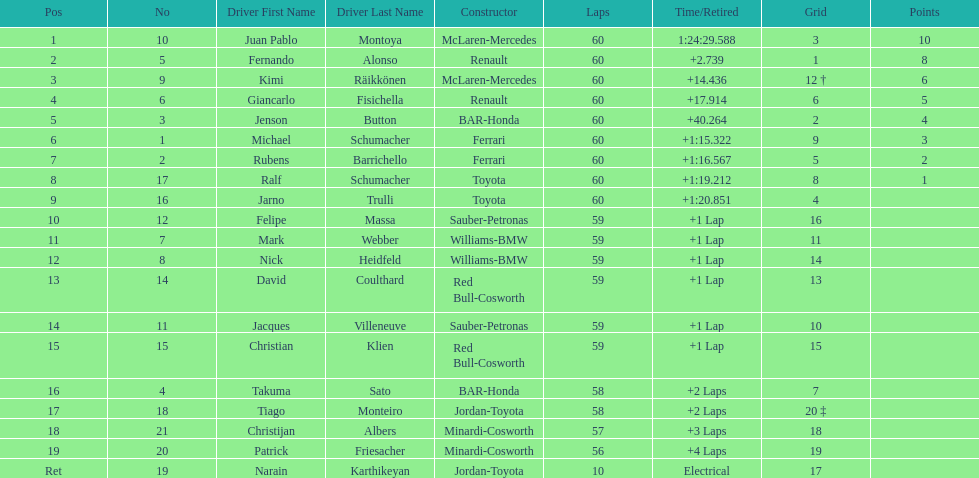Which driver in the top 8, drives a mclaran-mercedes but is not in first place? Kimi Räikkönen. 